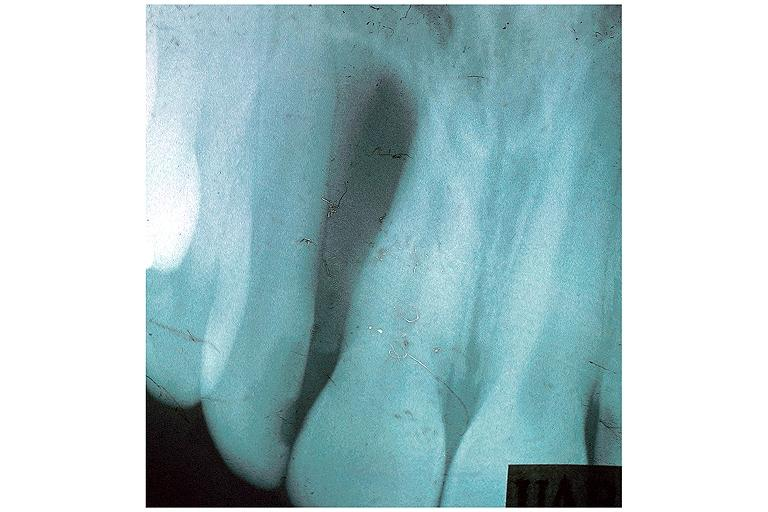what does this image show?
Answer the question using a single word or phrase. Globulomaxillary cyst 